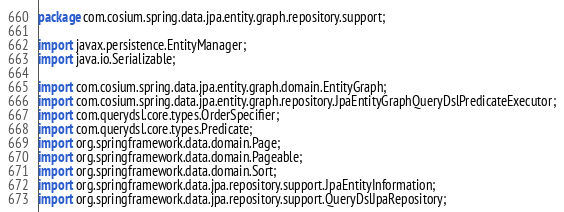<code> <loc_0><loc_0><loc_500><loc_500><_Java_>package com.cosium.spring.data.jpa.entity.graph.repository.support;

import javax.persistence.EntityManager;
import java.io.Serializable;

import com.cosium.spring.data.jpa.entity.graph.domain.EntityGraph;
import com.cosium.spring.data.jpa.entity.graph.repository.JpaEntityGraphQueryDslPredicateExecutor;
import com.querydsl.core.types.OrderSpecifier;
import com.querydsl.core.types.Predicate;
import org.springframework.data.domain.Page;
import org.springframework.data.domain.Pageable;
import org.springframework.data.domain.Sort;
import org.springframework.data.jpa.repository.support.JpaEntityInformation;
import org.springframework.data.jpa.repository.support.QueryDslJpaRepository;</code> 